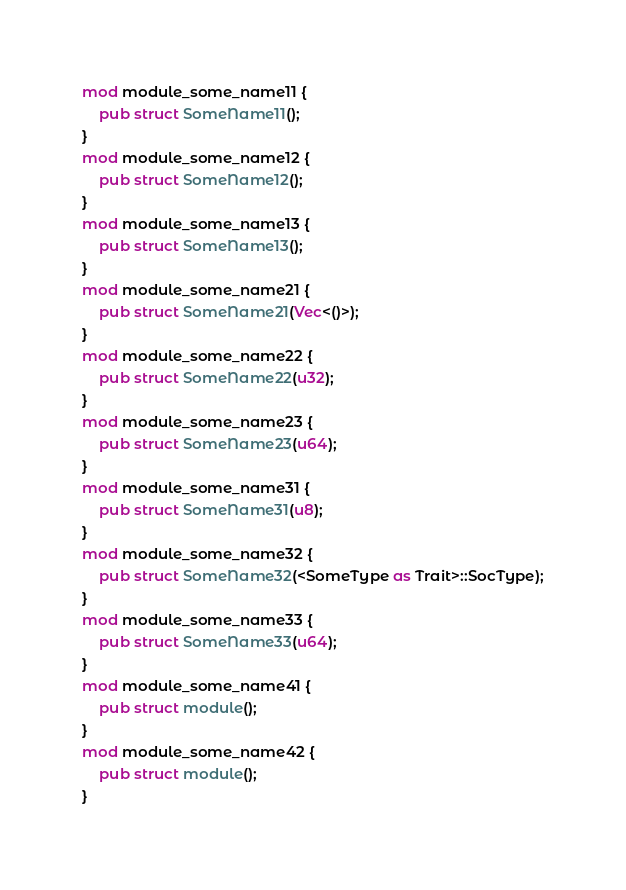Convert code to text. <code><loc_0><loc_0><loc_500><loc_500><_Rust_>mod module_some_name11 {
    pub struct SomeName11();
}
mod module_some_name12 {
    pub struct SomeName12();
}
mod module_some_name13 {
    pub struct SomeName13();
}
mod module_some_name21 {
    pub struct SomeName21(Vec<()>);
}
mod module_some_name22 {
    pub struct SomeName22(u32);
}
mod module_some_name23 {
    pub struct SomeName23(u64);
}
mod module_some_name31 {
    pub struct SomeName31(u8);
}
mod module_some_name32 {
    pub struct SomeName32(<SomeType as Trait>::SocType);
}
mod module_some_name33 {
    pub struct SomeName33(u64);
}
mod module_some_name41 {
    pub struct module();
}
mod module_some_name42 {
    pub struct module();
}</code> 